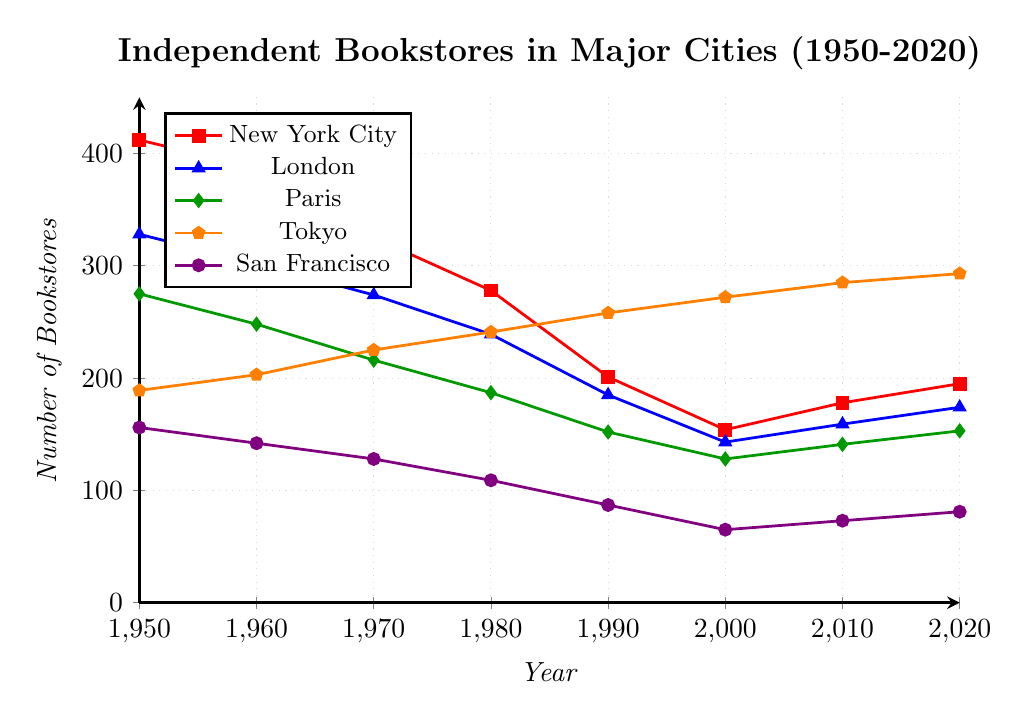What was the approximate difference in the number of bookstores between New York City and San Francisco in 1950? First, look up the number of bookstores in New York City (412) and San Francisco (156) in 1950. The difference is 412 - 156 = 256.
Answer: 256 Which city had the highest number of bookstores in 2020? Check the values for each city in 2020: New York City (195), London (174), Paris (153), Tokyo (293), and San Francisco (81). Tokyo has the highest number of bookstores.
Answer: Tokyo How many bookstores were there in London in 1980 and how does that compare to Paris in the same year? First, find London’s value in 1980 (239) and Paris’s value in 1980 (187). London had 239 - 187 = 52 more bookstores than Paris.
Answer: 52 more in London What was the trend in the number of bookstores in Tokyo from 1950 to 2020? Observe the values for Tokyo across the years: 1950 (189), 1960 (203), 1970 (225), 1980 (241), 1990 (258), 2000 (272), 2010 (285), 2020 (293). The number of bookstores consistently increased over these years.
Answer: Increased Between 1990 and 2000, which city saw the largest decrease in the number of independent bookstores? Calculate the decrease for each city between 1990 and 2000: New York City (201 to 154), London (185 to 143), Paris (152 to 128), Tokyo (258 to 272, an increase), San Francisco (87 to 65). The decrease is 201 - 154 = 47 for New York City, 185 - 143 = 42 for London, 152 - 128 = 24 for Paris, and 87 - 65 = 22 for San Francisco. New York City had the largest decrease.
Answer: New York City What was the average number of bookstores across all cities in 1970? Sum the number of bookstores for all cities in 1970: New York City (325), London (274), Paris (216), Tokyo (225), San Francisco (128). The sum is 325 + 274 + 216 + 225 + 128 = 1168. There are 5 cities, so the average is 1168 / 5 = 233.6.
Answer: 233.6 Which city had the smallest number of bookstores in any recorded year, and what was that number? Look for the smallest number across all cities and years: New York City’s smallest is 154 (2000), London’s is 143 (2000), Paris’s is 128 (2000), Tokyo's smallest is 189 (1950), and San Francisco's is 65 (2000). The smallest number is 65 in San Francisco in 2000.
Answer: San Francisco, 65 